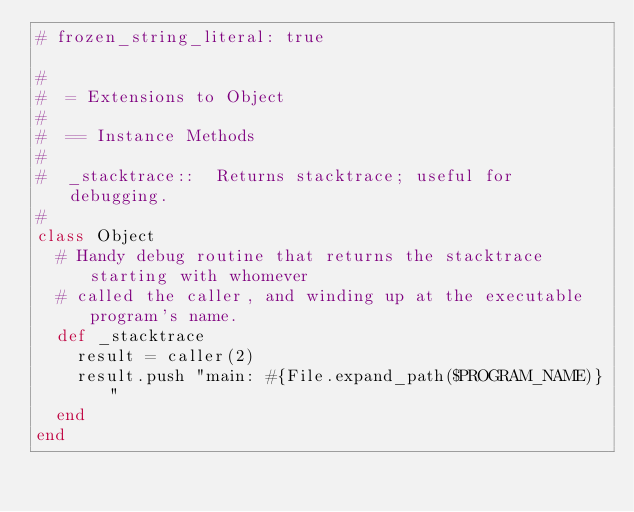<code> <loc_0><loc_0><loc_500><loc_500><_Ruby_># frozen_string_literal: true

#
#  = Extensions to Object
#
#  == Instance Methods
#
#  _stacktrace::  Returns stacktrace; useful for debugging.
#
class Object
  # Handy debug routine that returns the stacktrace starting with whomever
  # called the caller, and winding up at the executable program's name.
  def _stacktrace
    result = caller(2)
    result.push "main: #{File.expand_path($PROGRAM_NAME)}"
  end
end
</code> 